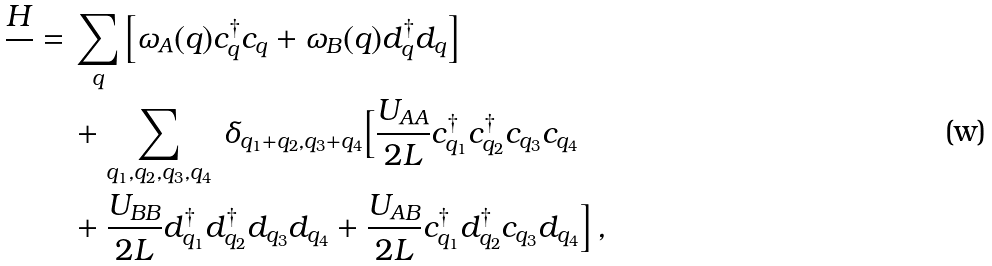Convert formula to latex. <formula><loc_0><loc_0><loc_500><loc_500>\frac { H } { } = & \, \sum _ { q } \left [ \omega _ { A } ( q ) c ^ { \dagger } _ { q } c _ { q } + \omega _ { B } ( q ) d ^ { \dagger } _ { q } d _ { q } \right ] \\ & \, + \sum _ { q _ { 1 } , q _ { 2 } , q _ { 3 } , q _ { 4 } } \, \delta _ { q _ { 1 } + q _ { 2 } , q _ { 3 } + q _ { 4 } } \Big { [ } \frac { U _ { A A } } { 2 L } c ^ { \dagger } _ { q _ { 1 } } c ^ { \dagger } _ { q _ { 2 } } c _ { q _ { 3 } } c _ { q _ { 4 } } \\ & \, + \frac { U _ { B B } } { 2 L } d ^ { \dagger } _ { q _ { 1 } } d ^ { \dagger } _ { q _ { 2 } } d _ { q _ { 3 } } d _ { q _ { 4 } } + \frac { U _ { A B } } { 2 L } c ^ { \dagger } _ { q _ { 1 } } d ^ { \dagger } _ { q _ { 2 } } c _ { q _ { 3 } } d _ { q _ { 4 } } \Big { ] } \, ,</formula> 